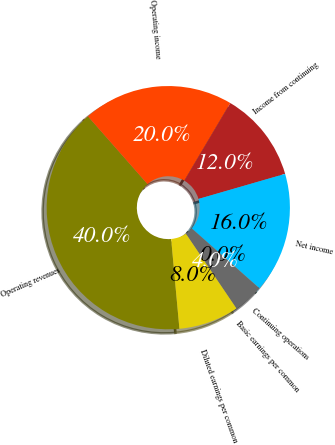<chart> <loc_0><loc_0><loc_500><loc_500><pie_chart><fcel>Operating revenues<fcel>Operating income<fcel>Income from continuing<fcel>Net income<fcel>Continuing operations<fcel>Basic earnings per common<fcel>Diluted earnings per common<nl><fcel>39.98%<fcel>20.0%<fcel>12.0%<fcel>16.0%<fcel>0.01%<fcel>4.01%<fcel>8.0%<nl></chart> 